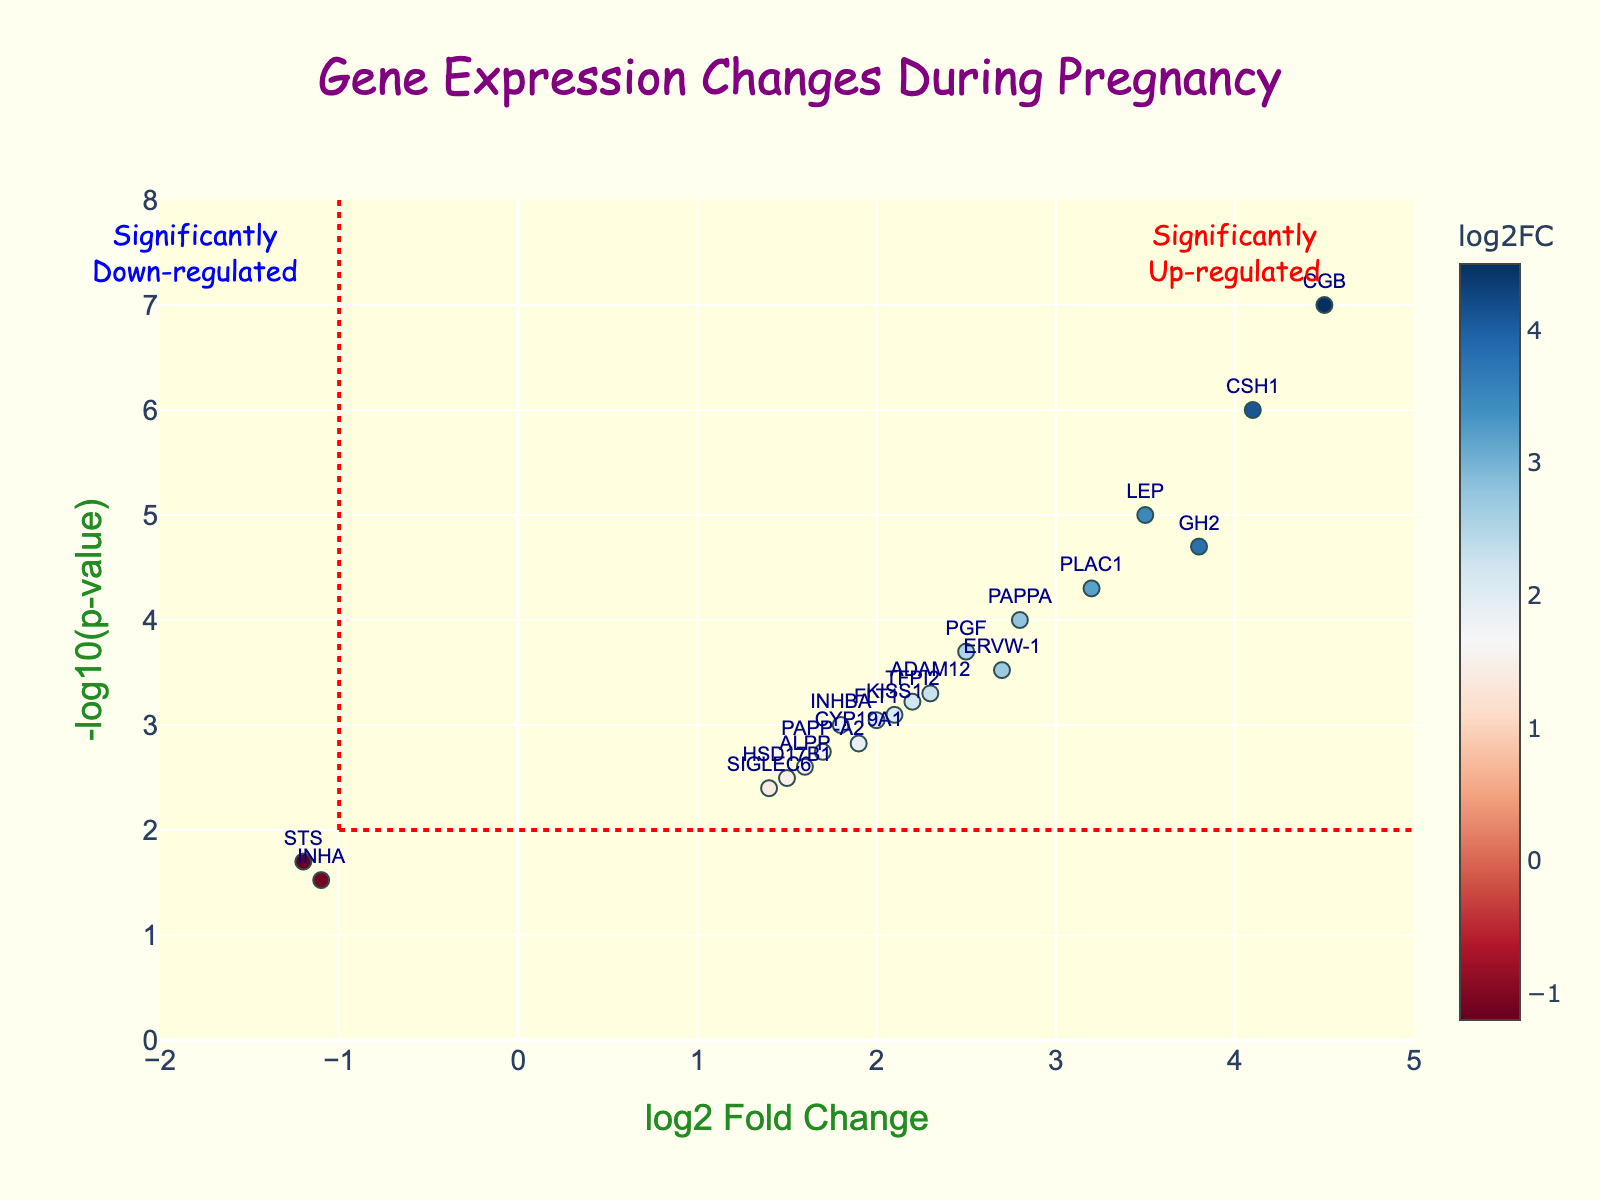What is the title of the figure? The title is located at the top of the figure. It says, "Gene Expression Changes During Pregnancy."
Answer: Gene Expression Changes During Pregnancy What does the y-axis represent? The y-axis title is located on the left side of the figure. It says "-log10(p-value)."
Answer: -log10(p-value) How many genes have a log2FoldChange greater than 2? To determine this, look at the x-axis for values greater than 2 and count the corresponding data points. The genes are CSH1, PLAC1, LEP, CGB, and GH2, making 5 genes.
Answer: 5 Which gene has the highest log2FoldChange? Check the x-axis for the most rightward data point. The gene with the highest log2FoldChange is CGB with a value of 4.5.
Answer: CGB What is the log2FoldChange for the gene named FLT1? Locate the gene FLT1 in the figure to find its log2FoldChange value. It is positioned at 2.0 on the x-axis.
Answer: 2.0 Which gene has the smallest p-value? The smallest p-value corresponds to the highest point on the y-axis. The gene at the highest point is CGB.
Answer: CGB How many genes are significantly up-regulated according to the red dashed lines on the figure? Look for points above the horizontal red dashed line at -log10(p-value) = 2 and to the right of the vertical red dashed line at log2FoldChange = 1. The significantly up-regulated genes are CSH1, PLAC1, LEP, CGB, GH2, PAPPA, CSF1, ADAM12, PGF, FLT1, TFPI2, and INHBA, a total of 12.
Answer: 12 Among the significantly up-regulated genes, which one has the highest -log10(p-value)? Within the significantly up-regulated area, CGB has the highest -log10(p-value).
Answer: CGB Which gene has the second-lowest log2FoldChange? To find this, identify the two smallest log2FoldChange values. Here, INHA has -1.1, and STS has -1.2. The second-lowest log2FoldChange is -1.1 for INHA.
Answer: INHA What is the -log10(p-value) for the gene named LEP? Locate the gene LEP on the figure and read its y-axis value, which represents -log10(p-value). The value is approximately 5.
Answer: 5 